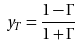<formula> <loc_0><loc_0><loc_500><loc_500>y _ { T } = \frac { 1 - \Gamma } { 1 + \Gamma }</formula> 